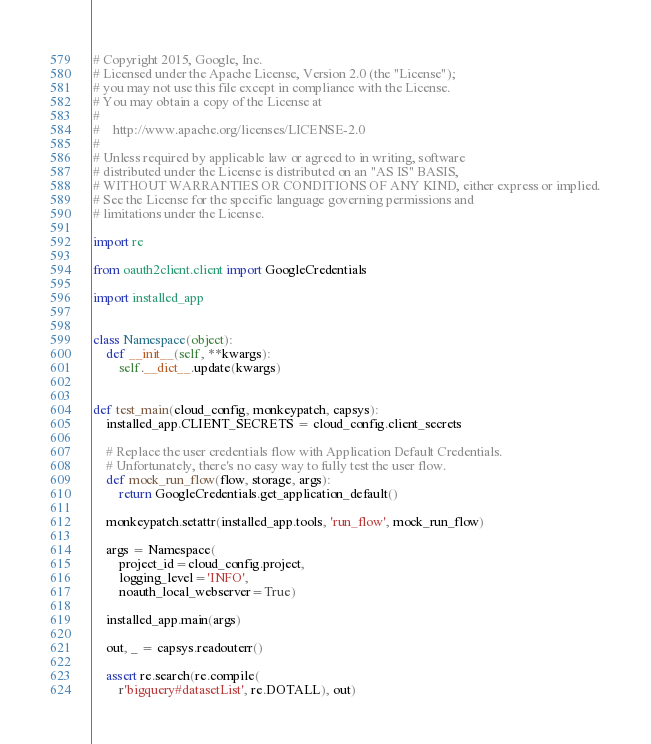Convert code to text. <code><loc_0><loc_0><loc_500><loc_500><_Python_># Copyright 2015, Google, Inc.
# Licensed under the Apache License, Version 2.0 (the "License");
# you may not use this file except in compliance with the License.
# You may obtain a copy of the License at
#
#    http://www.apache.org/licenses/LICENSE-2.0
#
# Unless required by applicable law or agreed to in writing, software
# distributed under the License is distributed on an "AS IS" BASIS,
# WITHOUT WARRANTIES OR CONDITIONS OF ANY KIND, either express or implied.
# See the License for the specific language governing permissions and
# limitations under the License.

import re

from oauth2client.client import GoogleCredentials

import installed_app


class Namespace(object):
    def __init__(self, **kwargs):
        self.__dict__.update(kwargs)


def test_main(cloud_config, monkeypatch, capsys):
    installed_app.CLIENT_SECRETS = cloud_config.client_secrets

    # Replace the user credentials flow with Application Default Credentials.
    # Unfortunately, there's no easy way to fully test the user flow.
    def mock_run_flow(flow, storage, args):
        return GoogleCredentials.get_application_default()

    monkeypatch.setattr(installed_app.tools, 'run_flow', mock_run_flow)

    args = Namespace(
        project_id=cloud_config.project,
        logging_level='INFO',
        noauth_local_webserver=True)

    installed_app.main(args)

    out, _ = capsys.readouterr()

    assert re.search(re.compile(
        r'bigquery#datasetList', re.DOTALL), out)
</code> 